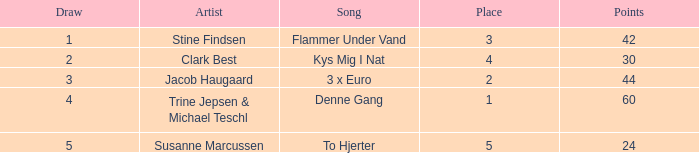What is the average Draw when the Place is larger than 5? None. 